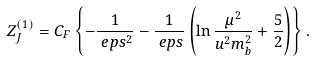Convert formula to latex. <formula><loc_0><loc_0><loc_500><loc_500>Z _ { J } ^ { ( 1 ) } & = C _ { F } \left \{ - \frac { 1 } { \ e p s ^ { 2 } } - \frac { 1 } { \ e p s } \left ( \ln \frac { \mu ^ { 2 } } { u ^ { 2 } m _ { b } ^ { 2 } } + \frac { 5 } { 2 } \right ) \right \} .</formula> 